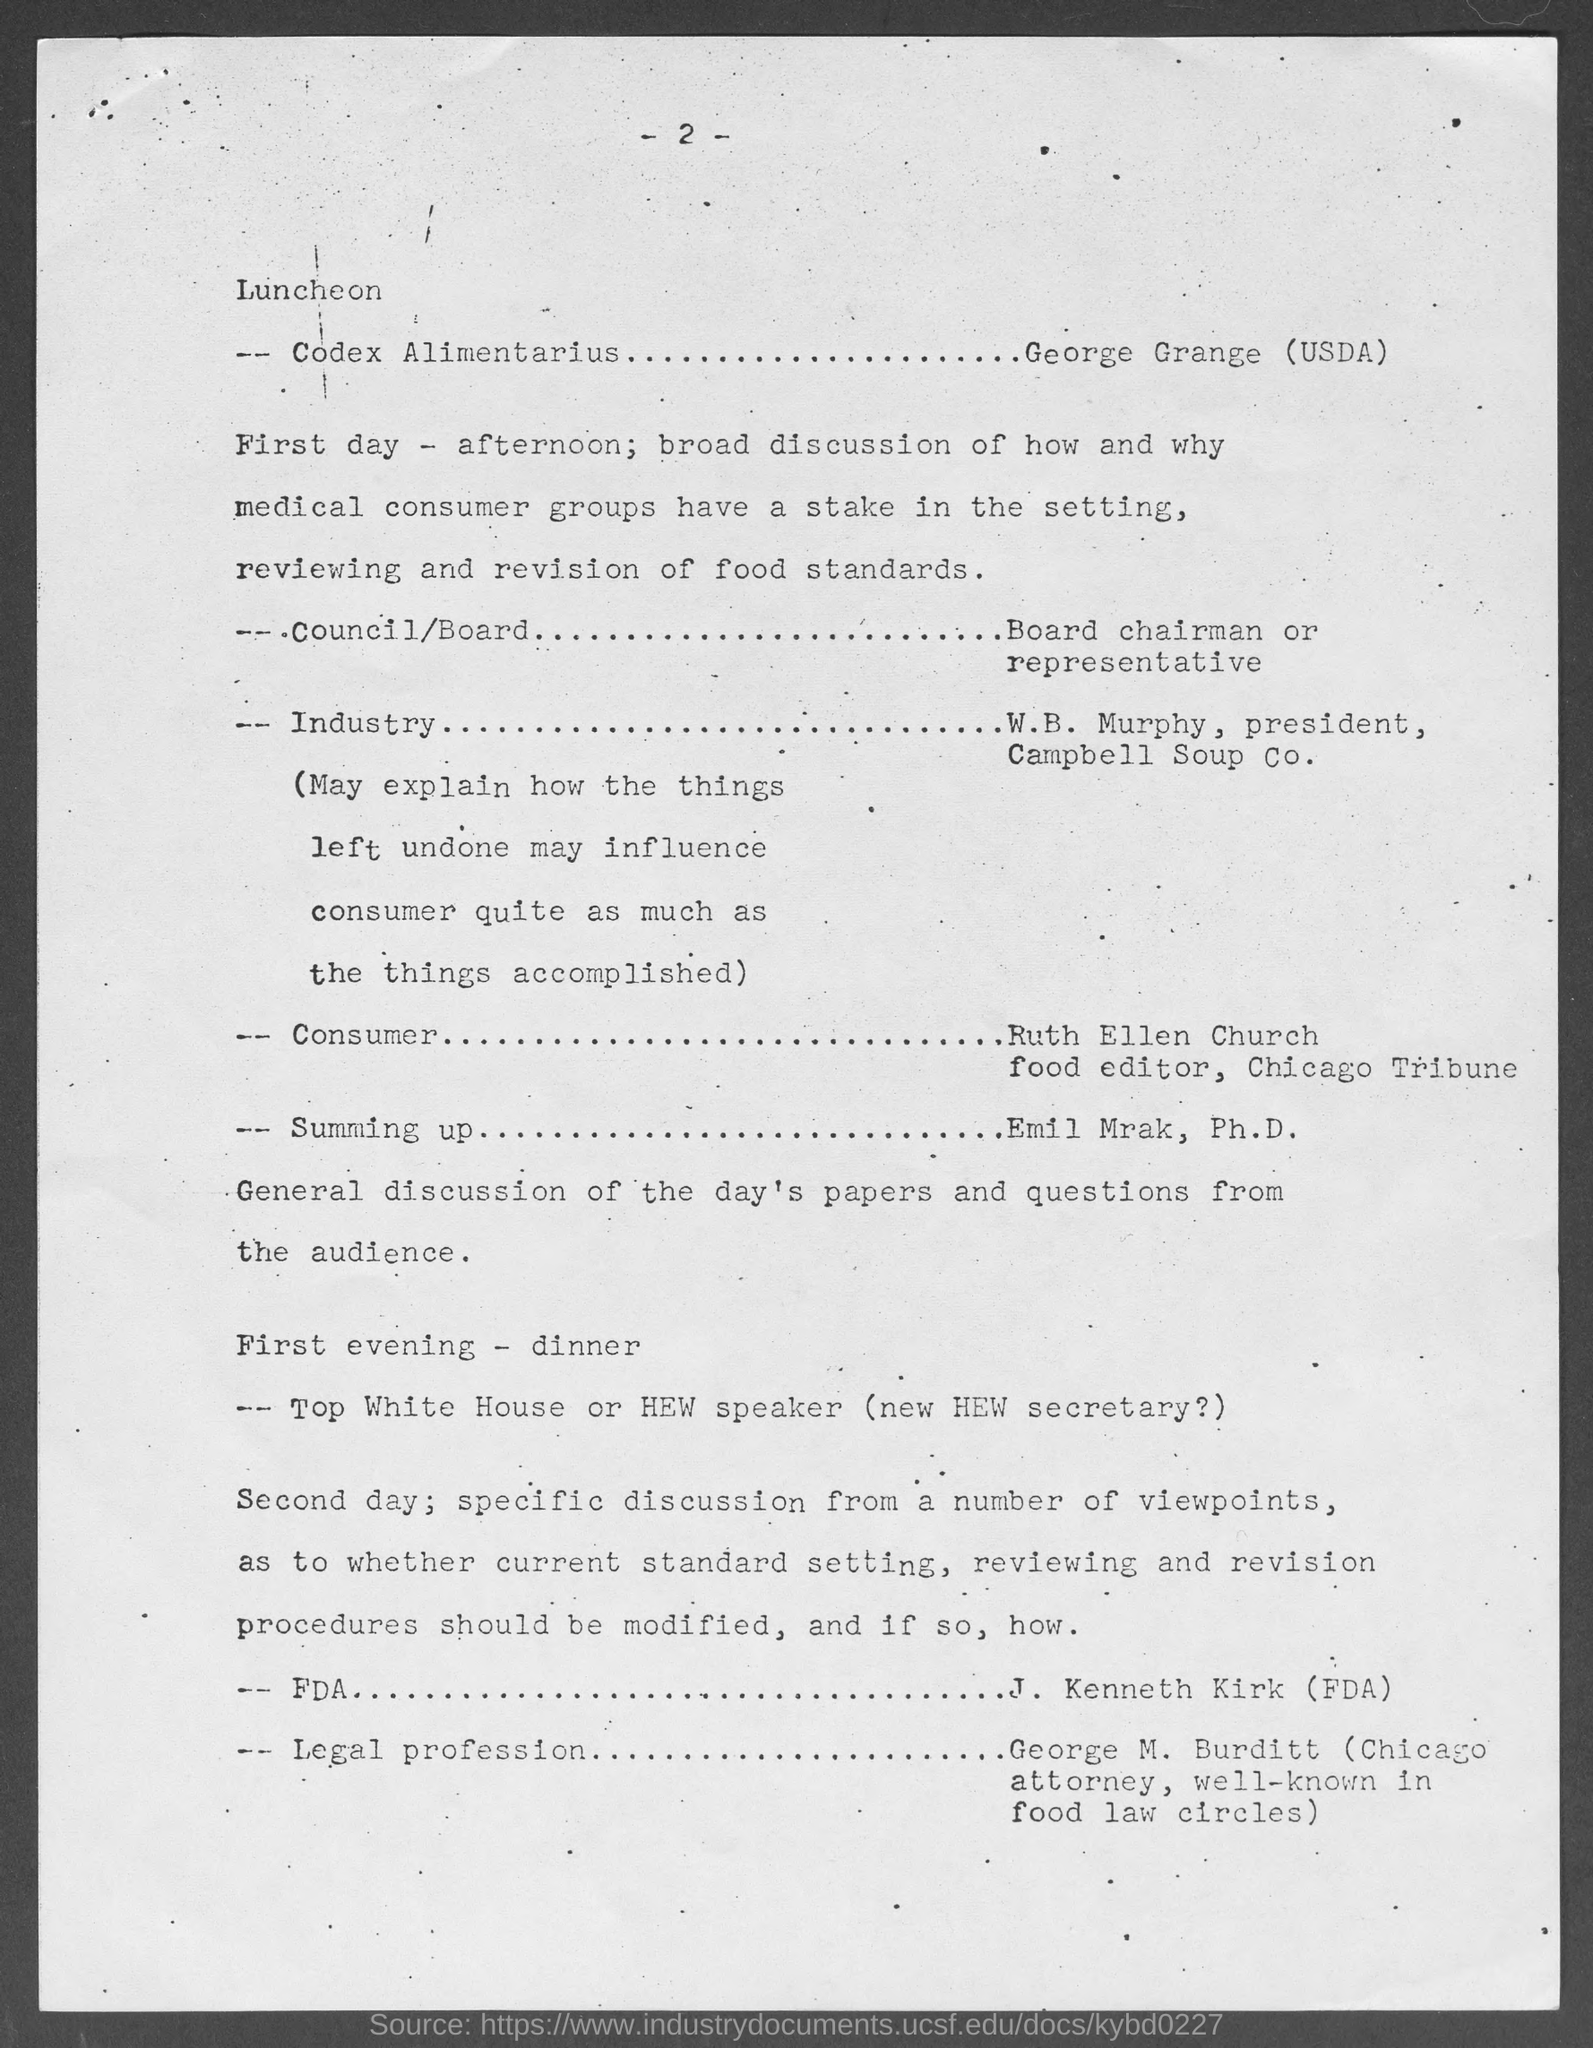Indicate a few pertinent items in this graphic. I am holding a page numbered 2. Campbell Soup Company's president is W.B. Murphy. 